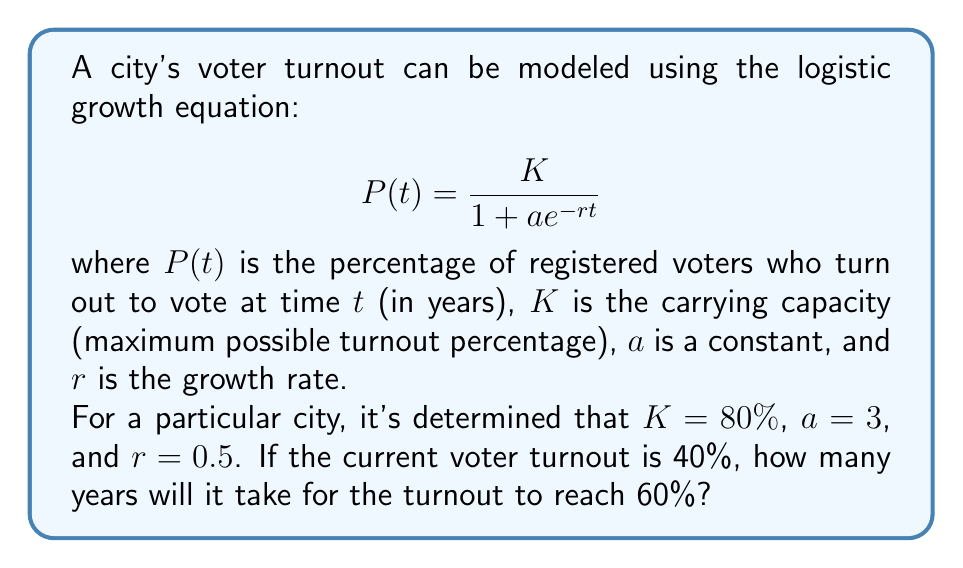Help me with this question. To solve this problem, we need to use the logistic growth equation and solve for $t$. Let's approach this step-by-step:

1) We're given that $K = 80\%$, $a = 3$, and $r = 0.5$. We want to find $t$ when $P(t) = 60\%$.

2) Let's substitute these values into the logistic growth equation:

   $$60 = \frac{80}{1 + 3e^{-0.5t}}$$

3) Now, let's solve this equation for $t$:

   Multiply both sides by $(1 + 3e^{-0.5t})$:
   $$60(1 + 3e^{-0.5t}) = 80$$

   Distribute on the left side:
   $$60 + 180e^{-0.5t} = 80$$

   Subtract 60 from both sides:
   $$180e^{-0.5t} = 20$$

   Divide both sides by 180:
   $$e^{-0.5t} = \frac{1}{9}$$

   Take the natural log of both sides:
   $$-0.5t = \ln(\frac{1}{9})$$

   Divide both sides by -0.5:
   $$t = -\frac{2\ln(\frac{1}{9})}{1} = 2\ln(9)$$

4) Calculate the final value:
   $$t \approx 4.39$$

Therefore, it will take approximately 4.39 years for the voter turnout to reach 60%.
Answer: 4.39 years 